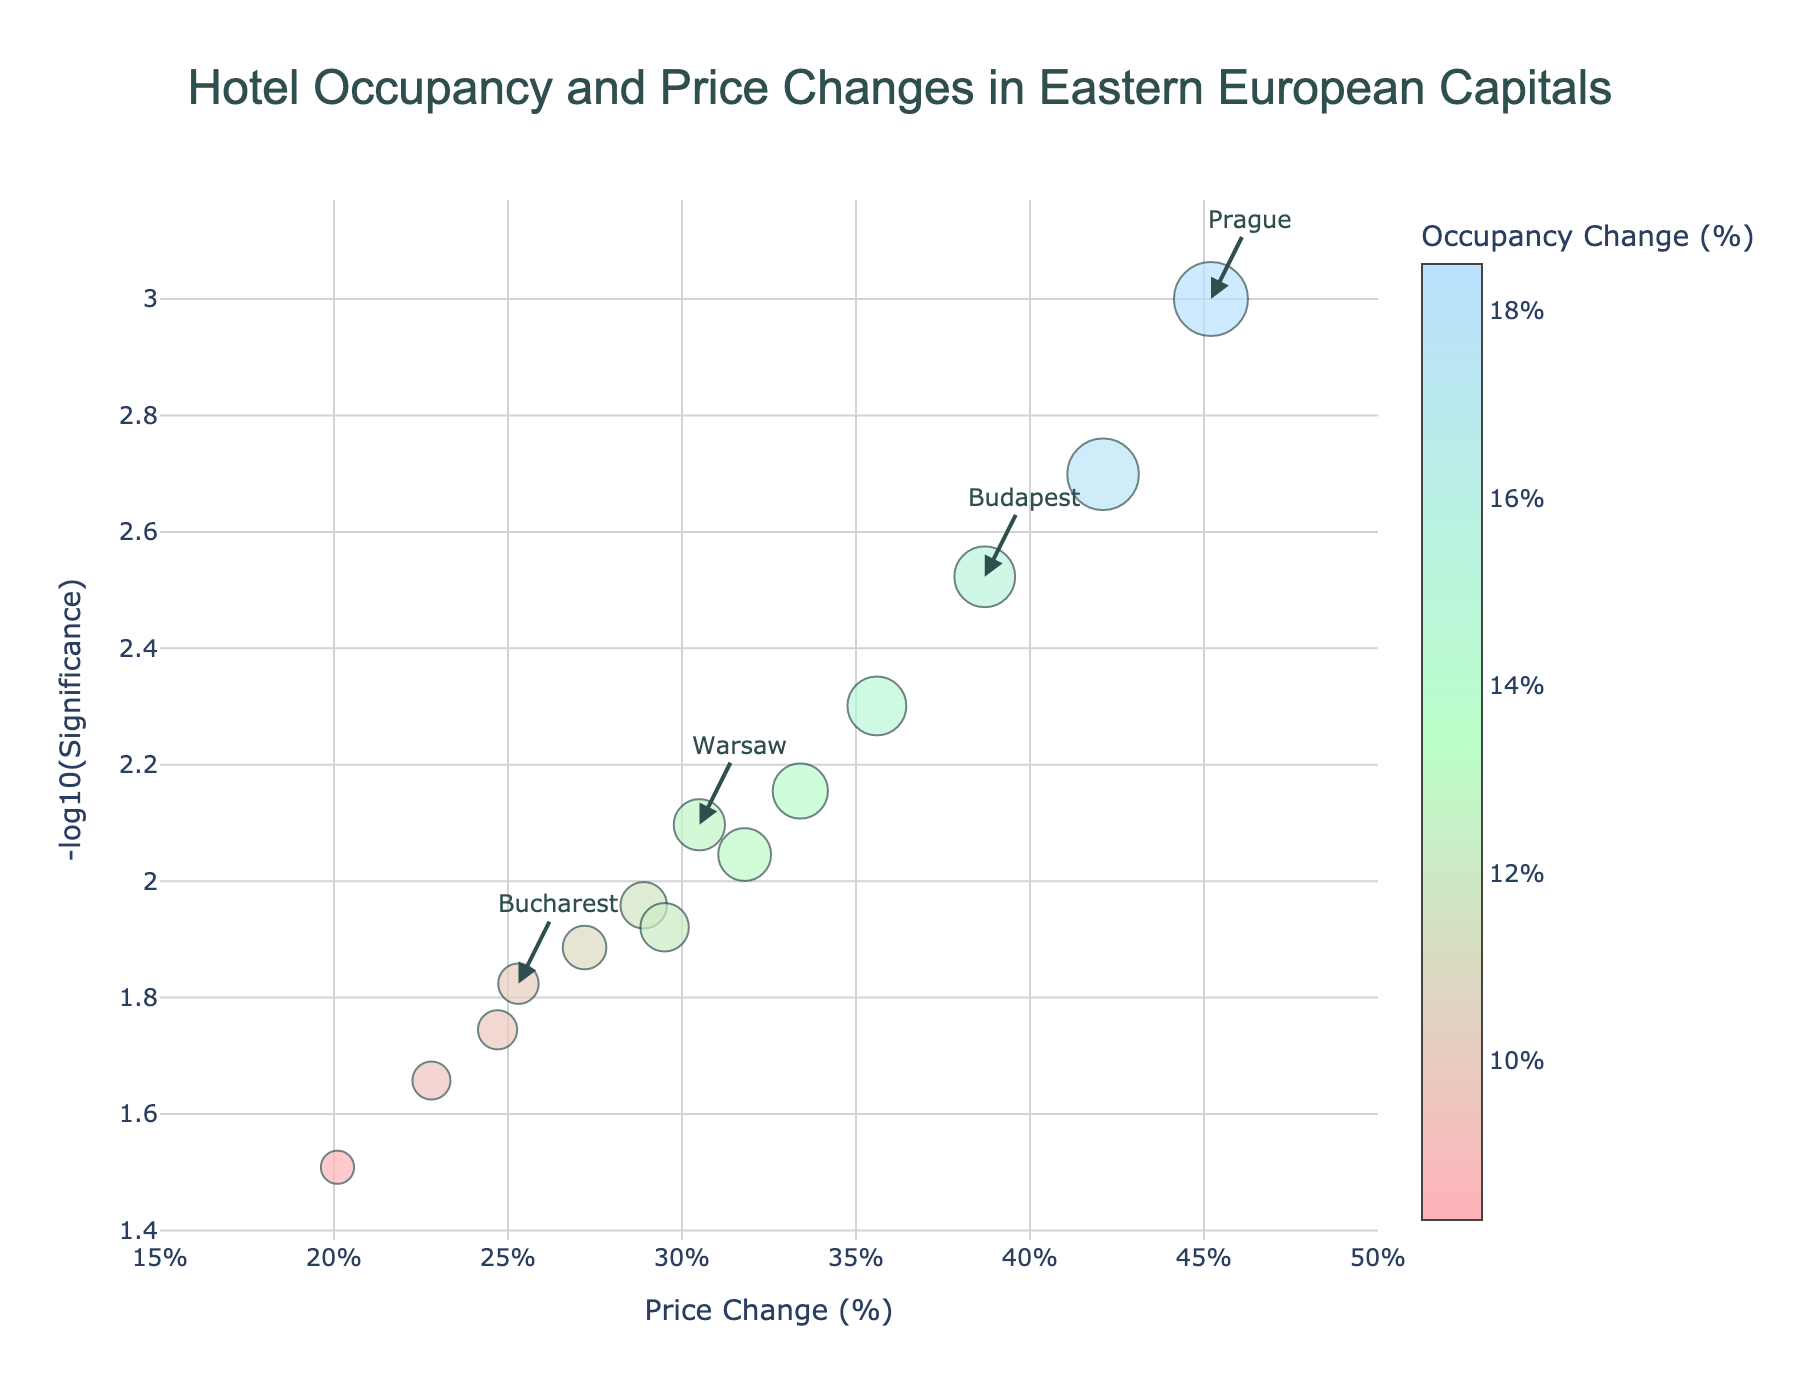What is the title of the figure? The title of the figure is displayed at the top center of the plot. The title text helps to understand what the plot is about.
Answer: Hotel Occupancy and Price Changes in Eastern European Capitals How many cities are represented in the plot? Each data point represents a city, and counting the data points or reviewing the dataset gives the total number of cities.
Answer: 14 Which city has the highest price change? Reviewing the x-axis points for each city, the city with the maximum x-value represents the highest price change.
Answer: Prague What is the significance (-log10(Significance)) for Prague? Locate Prague on the plot, and read the y-axis value associated with it.
Answer: Approximately 3.00 Which city has the lowest occupancy change? Find the data point with the smallest marker size, as marker size represents occupancy change.
Answer: Chisinau What is the average price change among the cities? Sum the 'PriceChange' values of all cities and divide by the number of cities. (45.2 + 38.7 + 30.5 + 42.1 + 25.3 + 22.8 + 35.6 + 28.9 + 27.2 + 33.4 + 31.8 + 29.5 + 24.7 + 20.1) / 14
Answer: 31.3% Which city has a higher price change, Budapest or Warsaw? Compare the x-axis values of Budapest and Warsaw.
Answer: Budapest What is the median occupancy change among the cities? List the 'OccupancyChange' values, sort them and find the middle value.
Answer: 12.8% Which city has the largest significance value? Determine the city with the highest y-axis value. Significance is represented in -log10, so the highest value corresponds to the smallest original significance.
Answer: Prague Between Budapest and Krakow, which city has a higher significance (-log10(Significance))? Compare the y-axis values of Budapest and Krakow.
Answer: Prague 